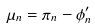<formula> <loc_0><loc_0><loc_500><loc_500>\mu _ { n } = \pi _ { n } - \phi _ { n } ^ { \prime }</formula> 